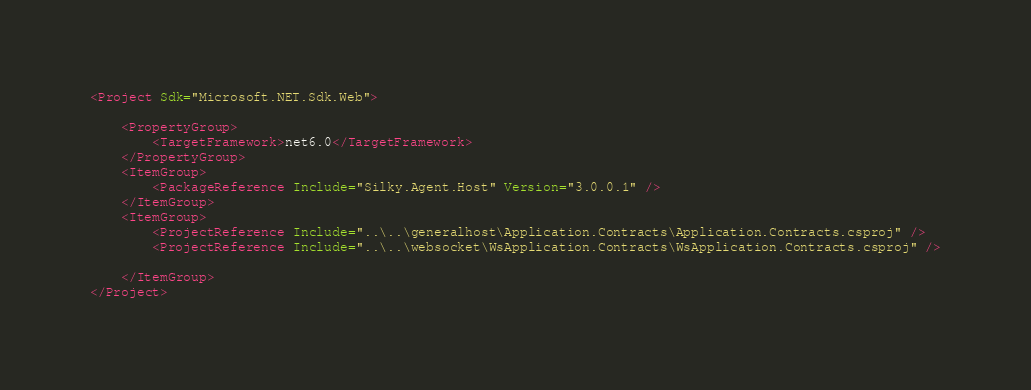Convert code to text. <code><loc_0><loc_0><loc_500><loc_500><_XML_><Project Sdk="Microsoft.NET.Sdk.Web">

    <PropertyGroup>
        <TargetFramework>net6.0</TargetFramework>
    </PropertyGroup>
    <ItemGroup>
        <PackageReference Include="Silky.Agent.Host" Version="3.0.0.1" />
    </ItemGroup>
    <ItemGroup>
        <ProjectReference Include="..\..\generalhost\Application.Contracts\Application.Contracts.csproj" />
        <ProjectReference Include="..\..\websocket\WsApplication.Contracts\WsApplication.Contracts.csproj" />

    </ItemGroup>
</Project>
</code> 